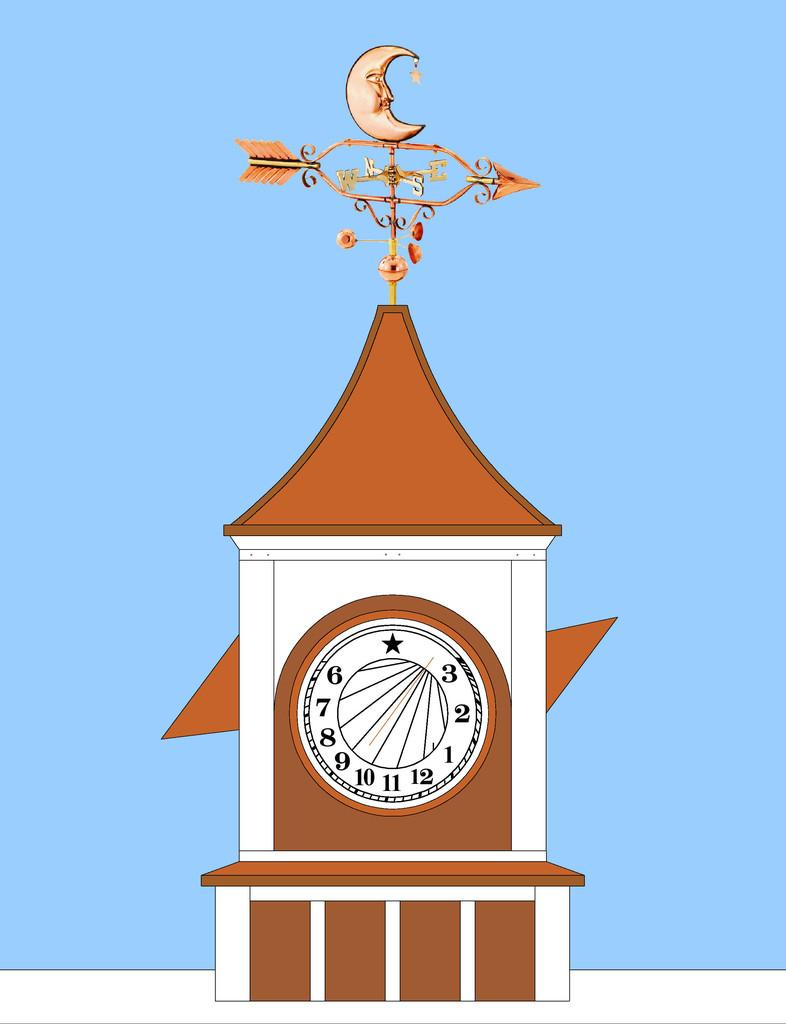<image>
Relay a brief, clear account of the picture shown. a clock tower is drawn with a star where the 12 normally is, and the numbers are all moved 